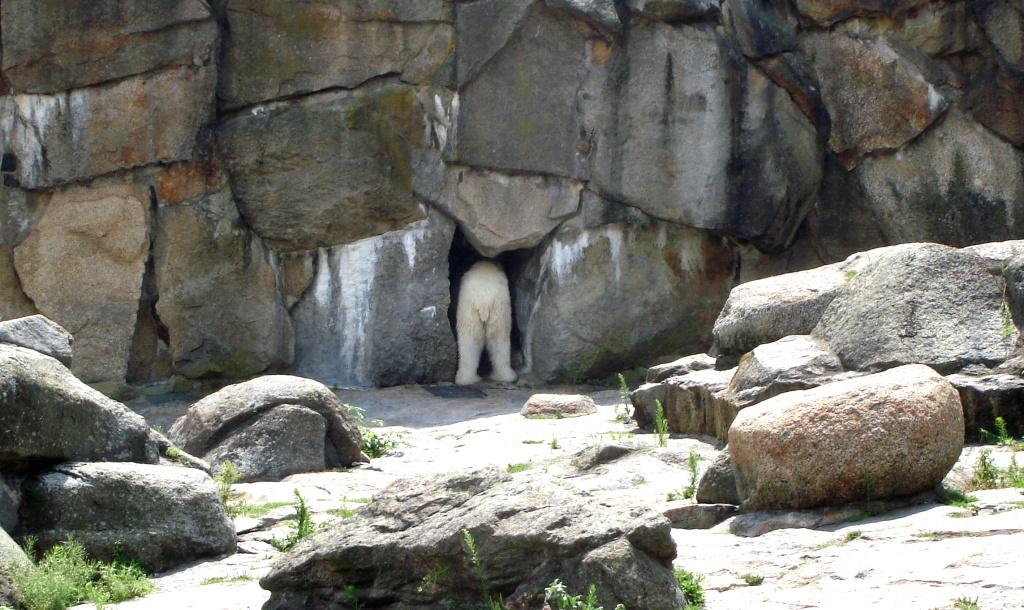What type of natural elements can be seen in the image? The image contains rocks. What animal is in the middle of the image? There is an animal in white color in the middle of the image. What type of vegetation is present on the ground in the image? Small plants are present on the ground in the image. How many bushes can be seen in the image? There are no bushes present in the image. Is the boy's uncle visible in the image? There is no boy or uncle mentioned or visible in the image. 